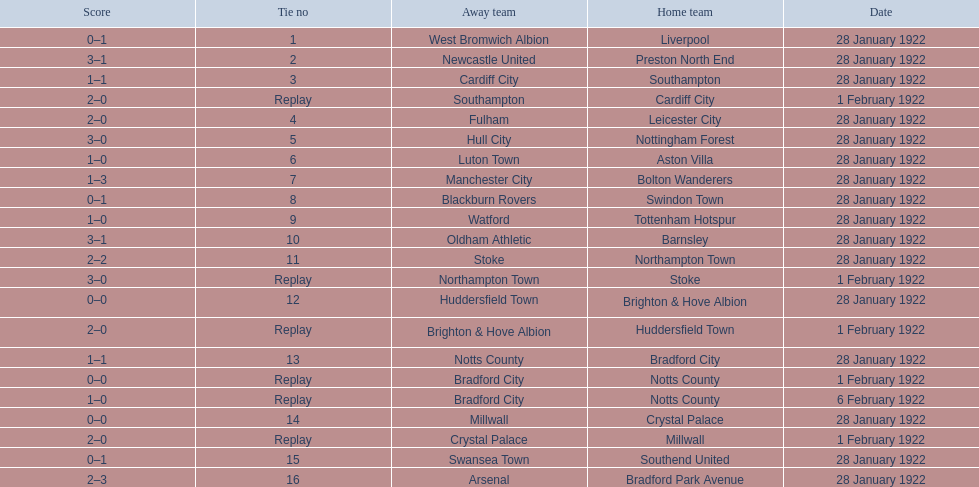What was the score in the aston villa game? 1–0. Which other team had an identical score? Tottenham Hotspur. 